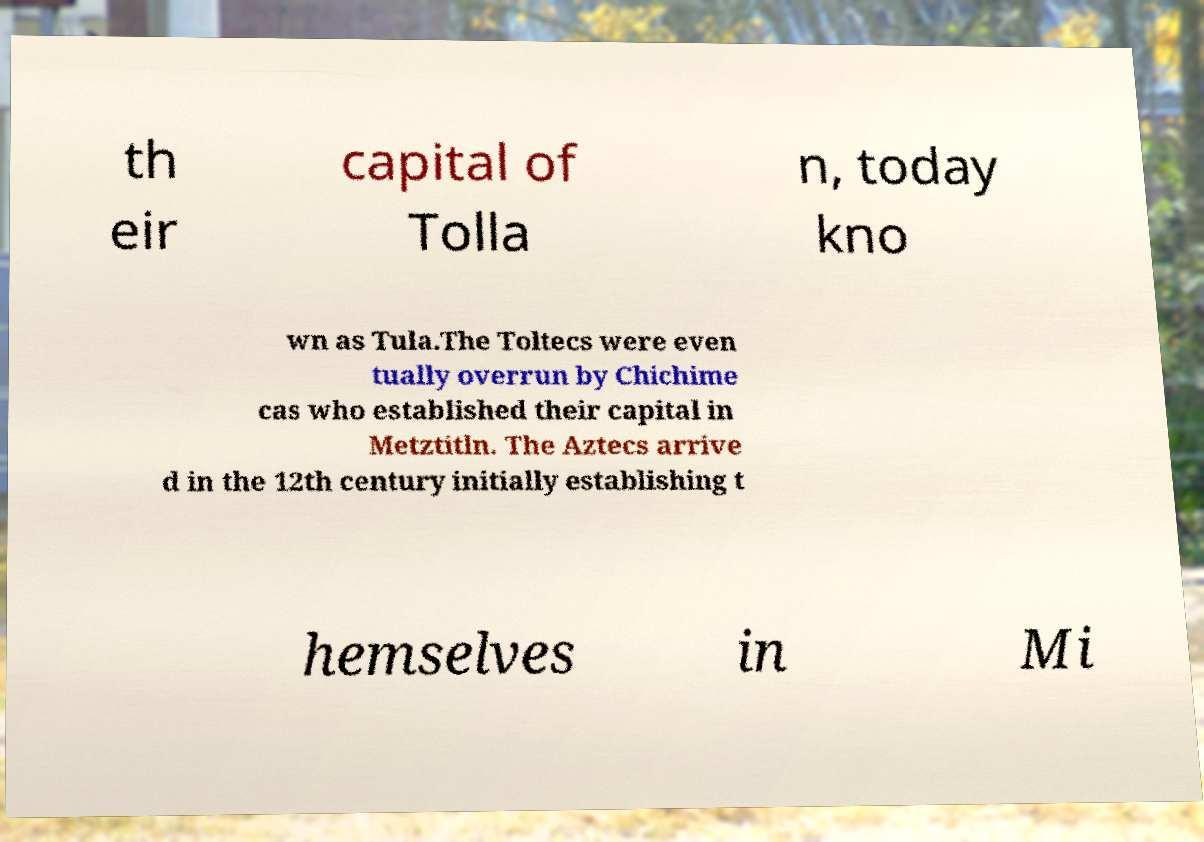I need the written content from this picture converted into text. Can you do that? th eir capital of Tolla n, today kno wn as Tula.The Toltecs were even tually overrun by Chichime cas who established their capital in Metztitln. The Aztecs arrive d in the 12th century initially establishing t hemselves in Mi 